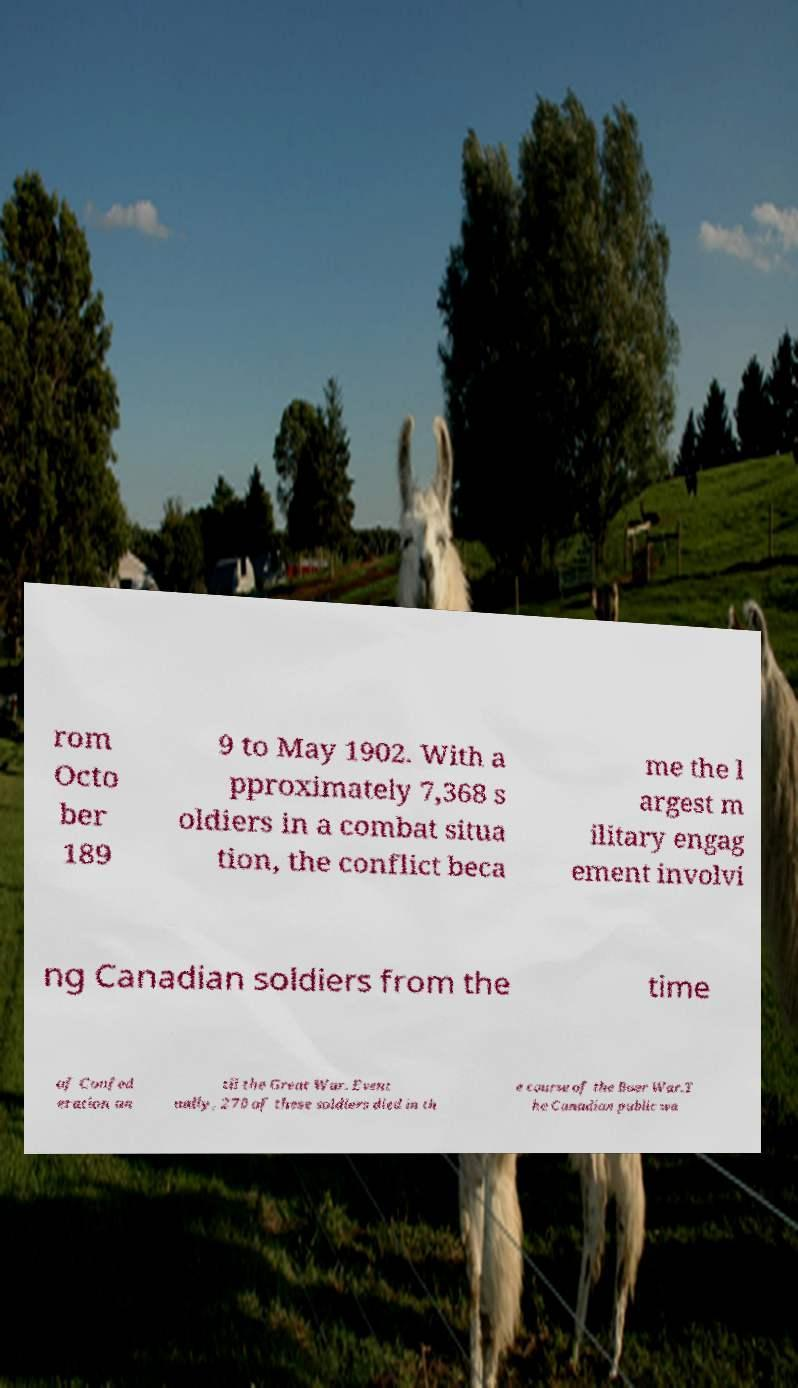Could you assist in decoding the text presented in this image and type it out clearly? rom Octo ber 189 9 to May 1902. With a pproximately 7,368 s oldiers in a combat situa tion, the conflict beca me the l argest m ilitary engag ement involvi ng Canadian soldiers from the time of Confed eration un til the Great War. Event ually, 270 of these soldiers died in th e course of the Boer War.T he Canadian public wa 